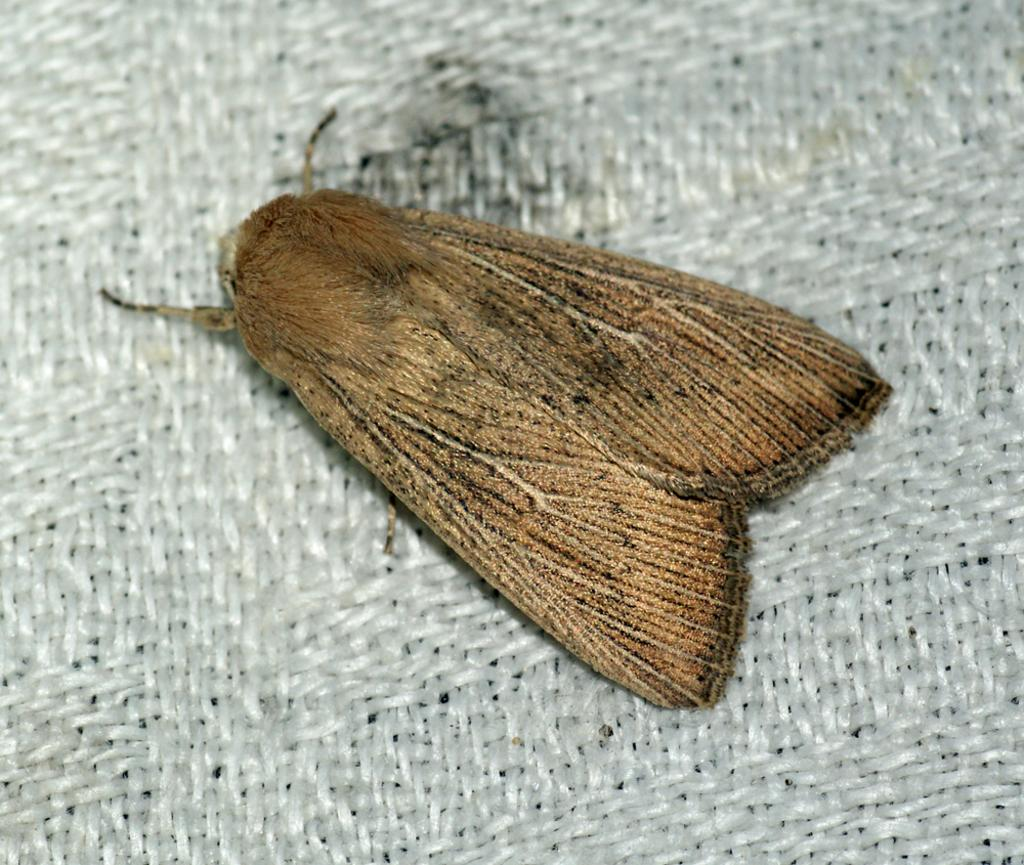What is the main subject of the image? There is a beautiful butterfly in the image. What is the butterfly resting on? The butterfly is on a white cloth. What type of drain is visible in the image? There is no drain present in the image; it features a beautiful butterfly on a white cloth. 